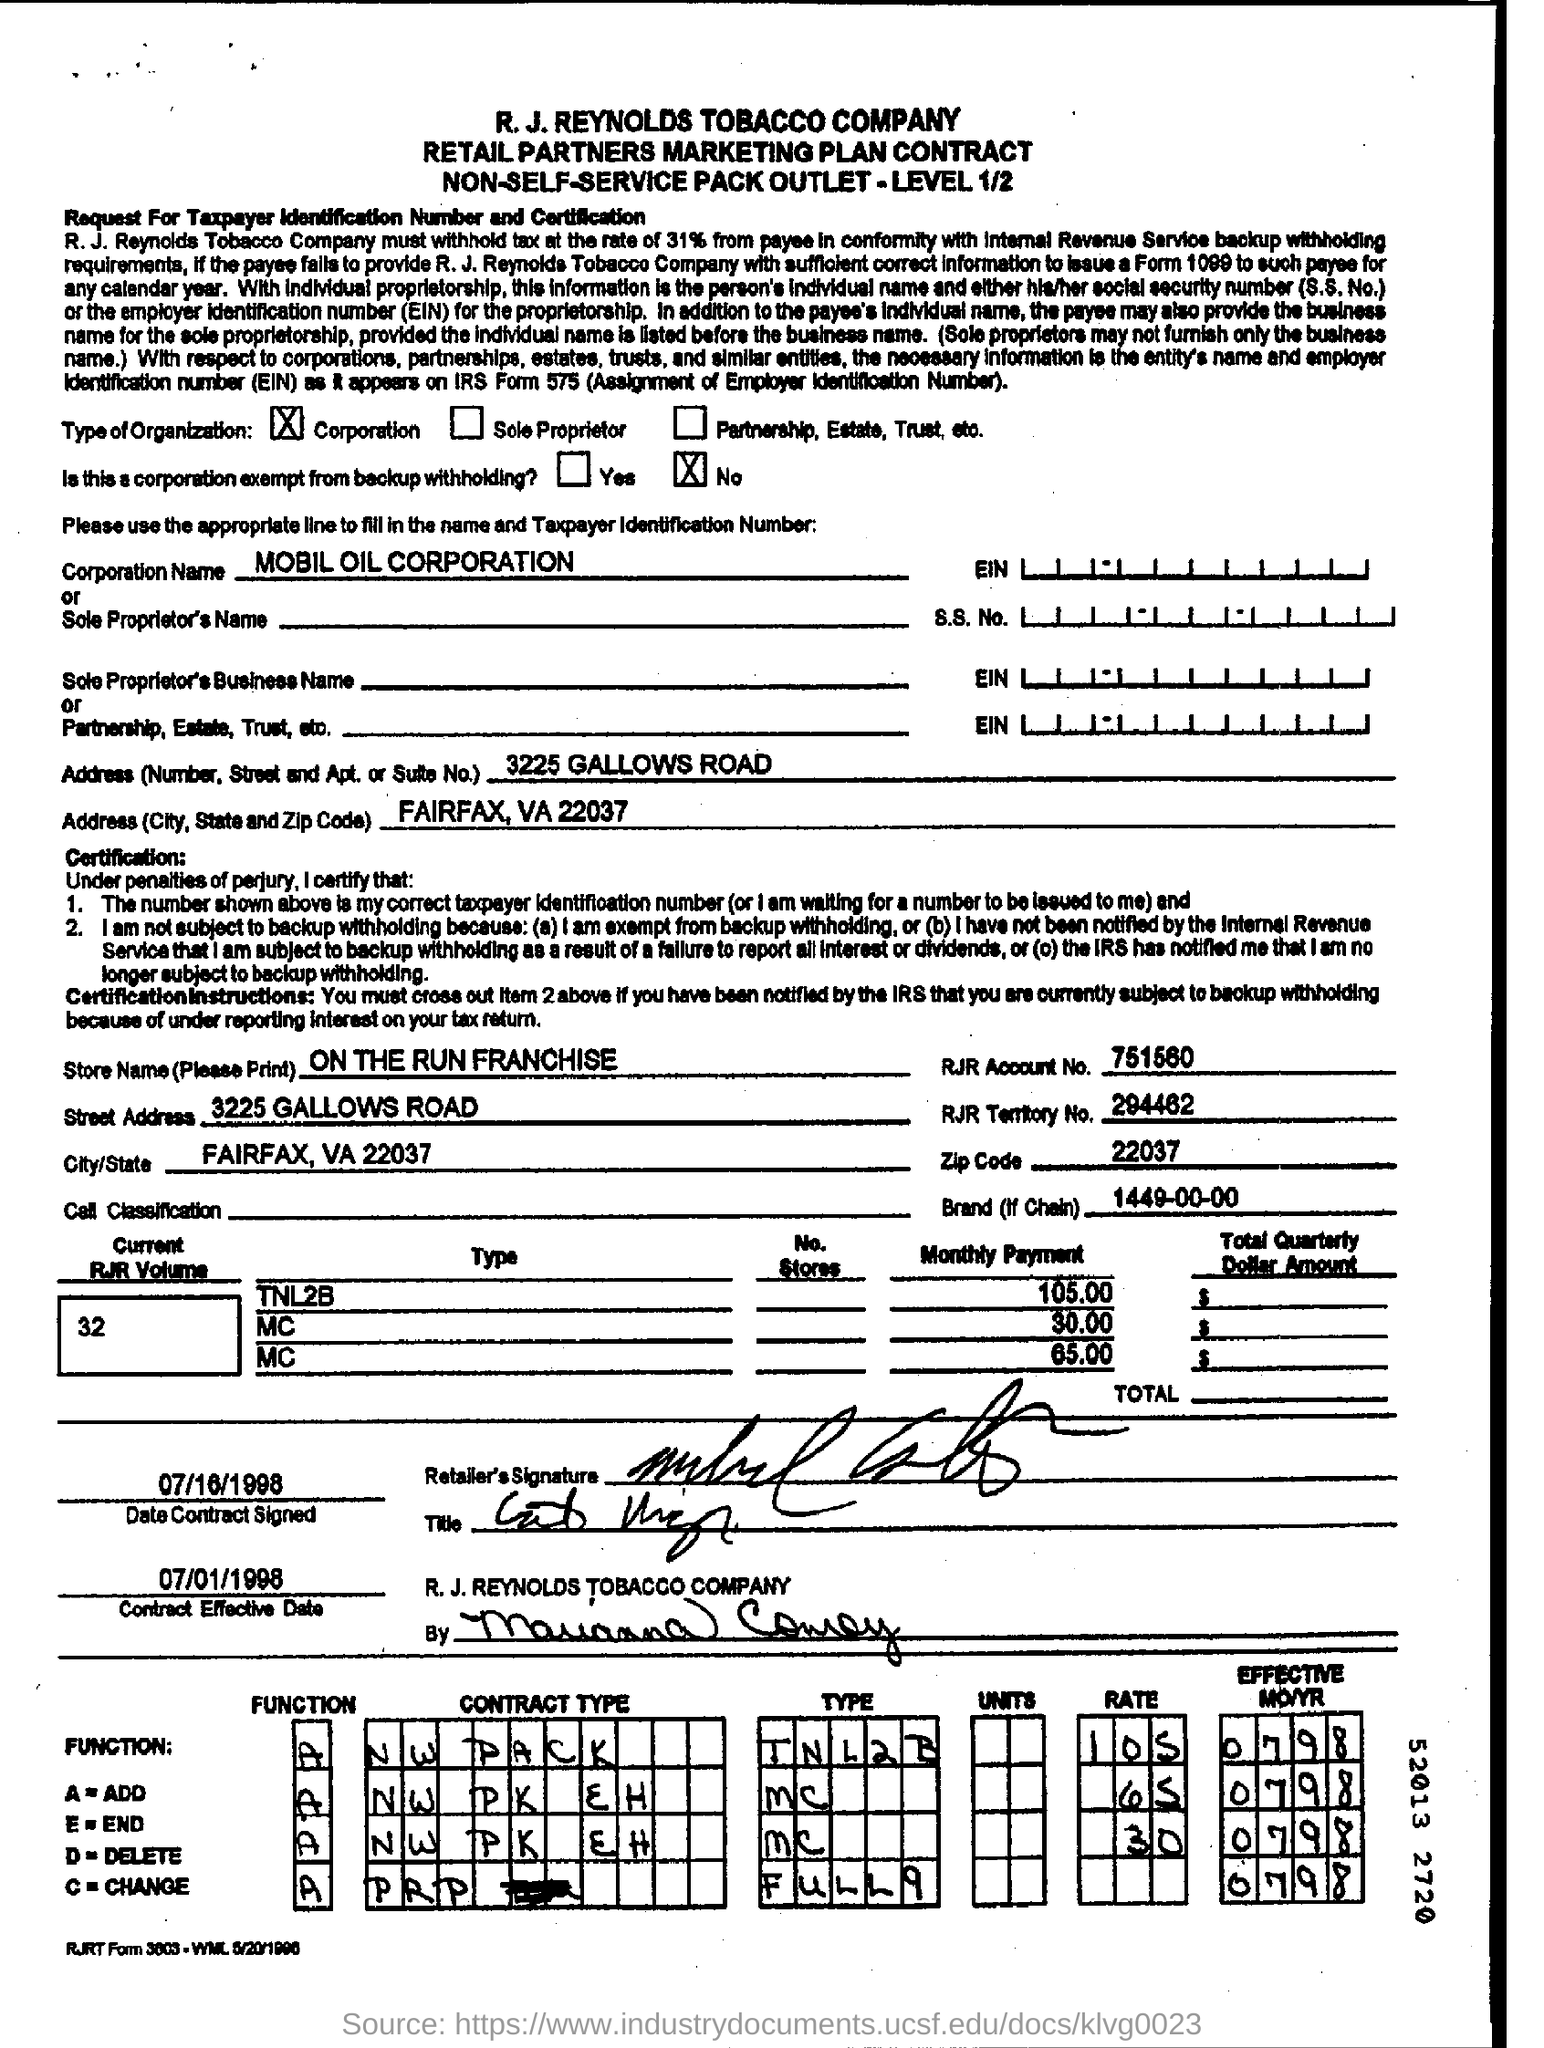Indicate a few pertinent items in this graphic. The zip code number is 22037. The corporation name is Mobil Oil Corporation. The name of the store is ON THE RUN FRANCHISE. The brand field contains the numerical value 1449-00-00... The Contract Effective Date is 07/01/1998. 